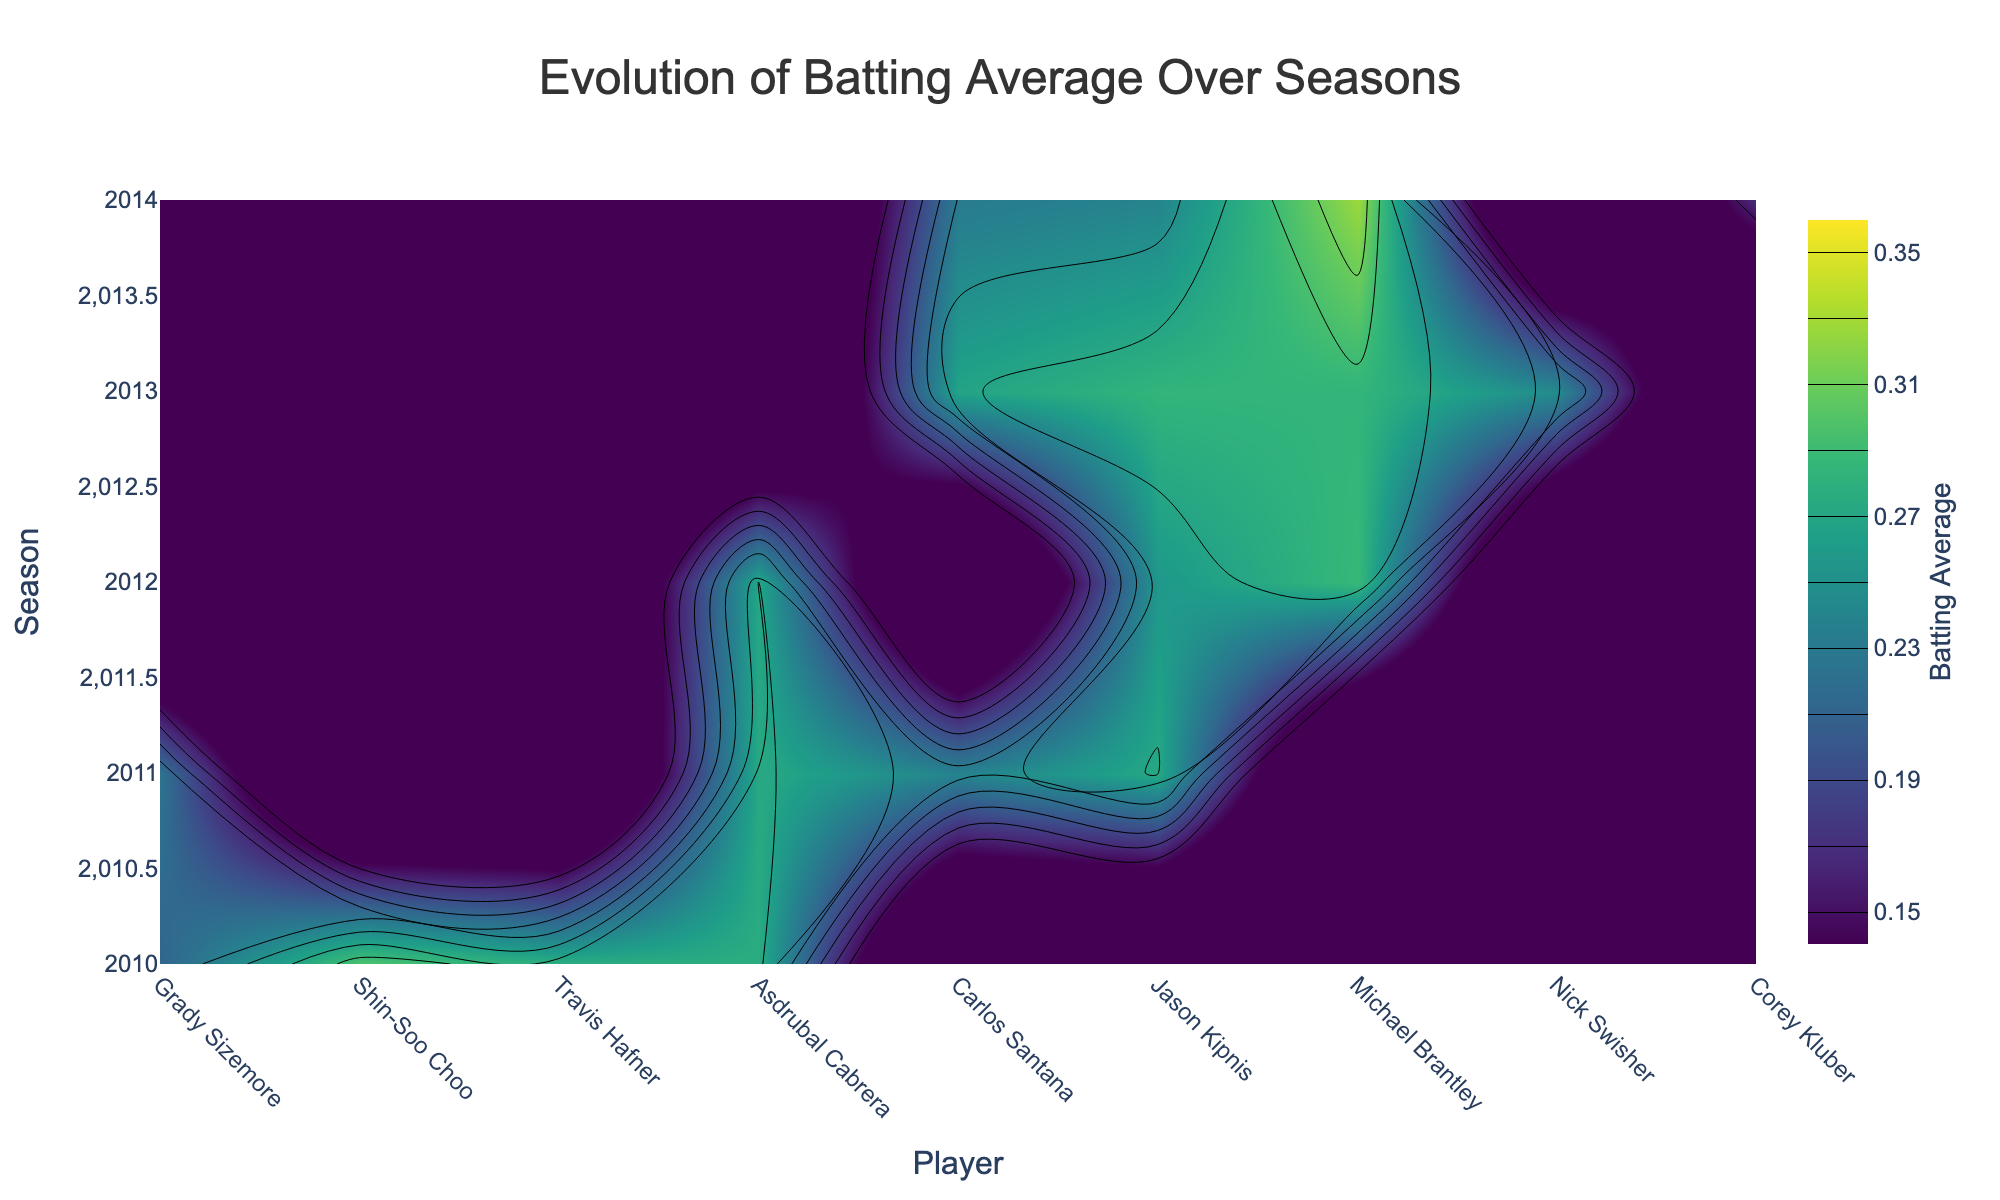what is the title of the plot? The title of the plot is written at the top and is visually distinguishable by its size and position.
Answer: Evolution of Batting Average Over Seasons Which player has the highest batting average in 2014? Look for the highest color intensity (darkest shade) in the 2014 row of the contour plot. The player with the highest intensity color in the 2014 row represents the highest batting average.
Answer: Michael Brantley Which season shows the overall lowest batting averages among players? Identify the season with the lighter color shades on average across all players. The lighter the color, the lower the batting average.
Answer: 2014 Who played in the most seasons based on the plot? Count the number of seasons (rows) each player's name (x-axis label) appears in the plot. The player with the most instances has played in the most seasons.
Answer: Asdrubal Cabrera Which player shows the most improvement in batting average from 2012 to 2013? Compare the color intensity of player's cell from 2012 to 2013 in the contour plot and identify the player whose cell color changes the most favorably (from lighter to darker).
Answer: Jason Kipnis In which season did Carlos Santana have his lowest batting average? Find Carlos Santana (x-axis label), and then check which season (y-axis) has the lightest shade of color corresponding to his column.
Answer: 2014 Was there any player who didn't have any change in batting average between any two consecutive seasons? Scan through the players' columns and check if any player's color intensity remains consistent between any two consecutive seasons. Look for no change in the shade.
Answer: Michael Brantley (2012 to 2013) How many players had a batting average greater than or equal to 0.300 in any season? Look for the darkest color shades (intensity above or around the middle of the highest intensity) in any player's column across all seasons. Count the number of different players with such colors.
Answer: 1 (Shin-Soo Choo in 2010, Michael Brantley in 2014) What is the average batting average of all players in the 2013 season? Estimate the average color intensity of the 2013 row by averaging out the intensity values (shade colors) for each player in that row.
Answer: 0.270 